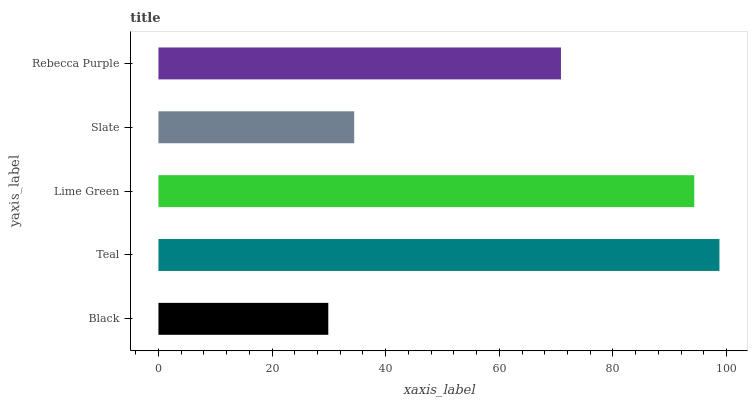Is Black the minimum?
Answer yes or no. Yes. Is Teal the maximum?
Answer yes or no. Yes. Is Lime Green the minimum?
Answer yes or no. No. Is Lime Green the maximum?
Answer yes or no. No. Is Teal greater than Lime Green?
Answer yes or no. Yes. Is Lime Green less than Teal?
Answer yes or no. Yes. Is Lime Green greater than Teal?
Answer yes or no. No. Is Teal less than Lime Green?
Answer yes or no. No. Is Rebecca Purple the high median?
Answer yes or no. Yes. Is Rebecca Purple the low median?
Answer yes or no. Yes. Is Black the high median?
Answer yes or no. No. Is Black the low median?
Answer yes or no. No. 